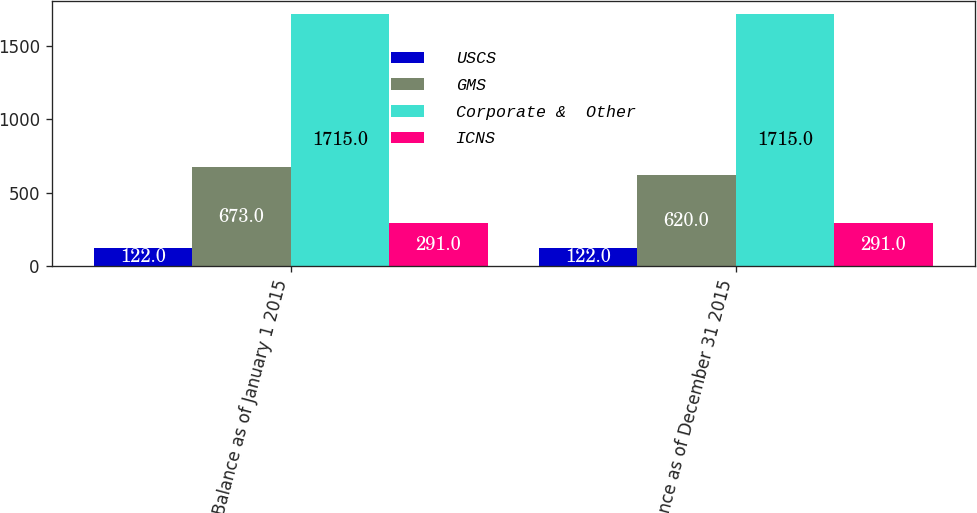<chart> <loc_0><loc_0><loc_500><loc_500><stacked_bar_chart><ecel><fcel>Balance as of January 1 2015<fcel>Balance as of December 31 2015<nl><fcel>USCS<fcel>122<fcel>122<nl><fcel>GMS<fcel>673<fcel>620<nl><fcel>Corporate &  Other<fcel>1715<fcel>1715<nl><fcel>ICNS<fcel>291<fcel>291<nl></chart> 